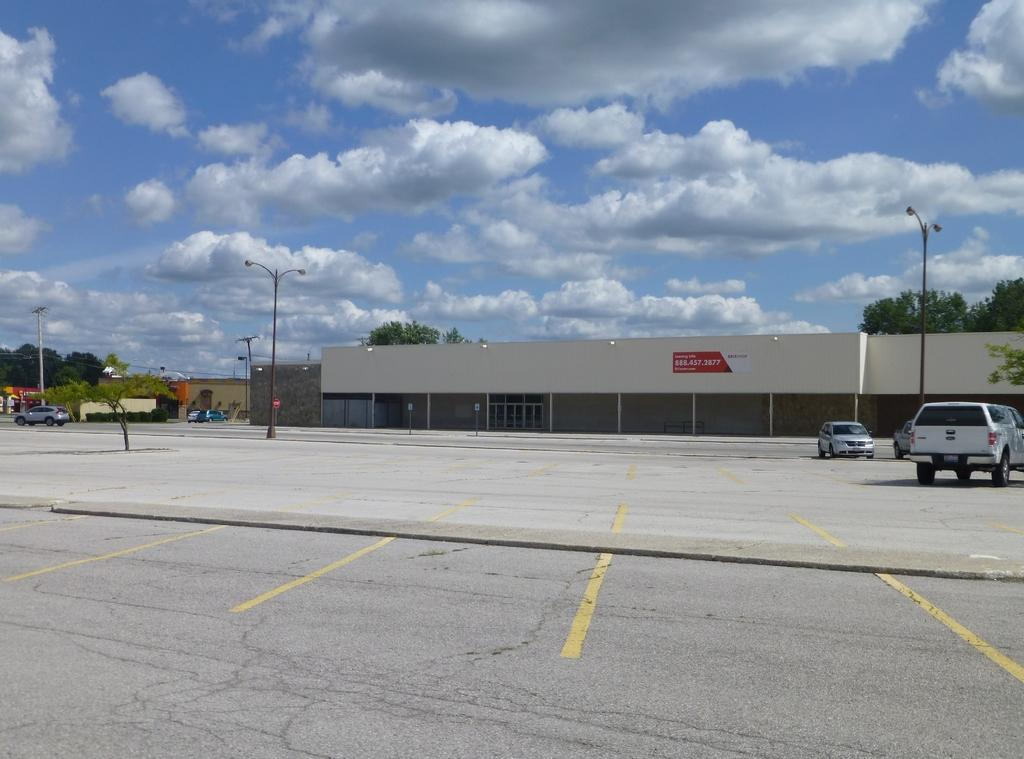What type of structures can be seen in the image? There are buildings in the image. What other natural elements are present in the image? There are trees in the image. What are the light sources in the image? There are light poles in the image. How would you describe the weather in the image? The sky is cloudy in the image. What type of objects can be seen on the ground in the image? There are vehicles on the ground in the image. How many bikes are being used by the people in the image? There are no bikes present in the image. What type of cheese is being served at the event in the image? There is no event or cheese present in the image. 